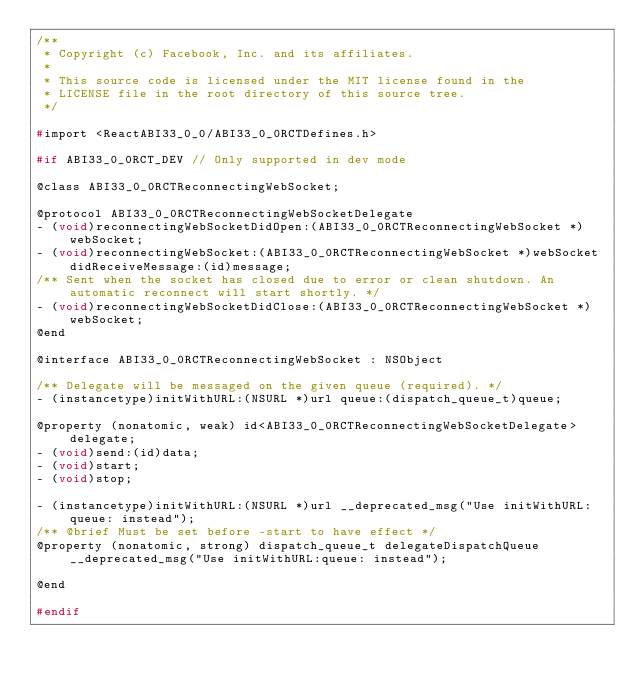<code> <loc_0><loc_0><loc_500><loc_500><_C_>/**
 * Copyright (c) Facebook, Inc. and its affiliates.
 *
 * This source code is licensed under the MIT license found in the
 * LICENSE file in the root directory of this source tree.
 */

#import <ReactABI33_0_0/ABI33_0_0RCTDefines.h>

#if ABI33_0_0RCT_DEV // Only supported in dev mode

@class ABI33_0_0RCTReconnectingWebSocket;

@protocol ABI33_0_0RCTReconnectingWebSocketDelegate
- (void)reconnectingWebSocketDidOpen:(ABI33_0_0RCTReconnectingWebSocket *)webSocket;
- (void)reconnectingWebSocket:(ABI33_0_0RCTReconnectingWebSocket *)webSocket didReceiveMessage:(id)message;
/** Sent when the socket has closed due to error or clean shutdown. An automatic reconnect will start shortly. */
- (void)reconnectingWebSocketDidClose:(ABI33_0_0RCTReconnectingWebSocket *)webSocket;
@end

@interface ABI33_0_0RCTReconnectingWebSocket : NSObject

/** Delegate will be messaged on the given queue (required). */
- (instancetype)initWithURL:(NSURL *)url queue:(dispatch_queue_t)queue;

@property (nonatomic, weak) id<ABI33_0_0RCTReconnectingWebSocketDelegate> delegate;
- (void)send:(id)data;
- (void)start;
- (void)stop;

- (instancetype)initWithURL:(NSURL *)url __deprecated_msg("Use initWithURL:queue: instead");
/** @brief Must be set before -start to have effect */
@property (nonatomic, strong) dispatch_queue_t delegateDispatchQueue __deprecated_msg("Use initWithURL:queue: instead");

@end

#endif
</code> 